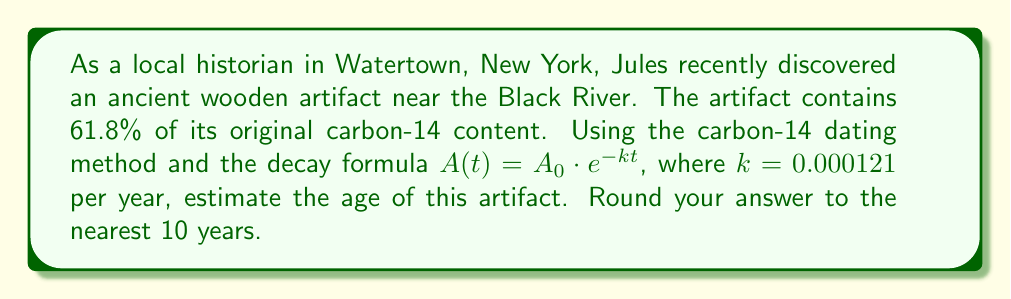Help me with this question. Let's approach this problem step-by-step using the logarithmic function to solve for time:

1) The decay formula is given as $A(t) = A_0 \cdot e^{-kt}$, where:
   $A(t)$ is the amount remaining after time $t$
   $A_0$ is the initial amount
   $k$ is the decay constant (0.000121 per year)
   $t$ is the time in years

2) We know that 61.8% of the original carbon-14 remains, so:
   $\frac{A(t)}{A_0} = 0.618$

3) Substituting this into our formula:
   $0.618 = e^{-0.000121t}$

4) To solve for $t$, we need to use the natural logarithm (ln) on both sides:
   $\ln(0.618) = \ln(e^{-0.000121t})$

5) The right side simplifies due to the properties of logarithms:
   $\ln(0.618) = -0.000121t$

6) Now we can solve for $t$:
   $t = \frac{\ln(0.618)}{-0.000121}$

7) Using a calculator:
   $t = \frac{-0.48120}{-0.000121} \approx 3977.69$ years

8) Rounding to the nearest 10 years:
   $t \approx 3980$ years
Answer: The estimated age of the artifact is approximately 3980 years. 